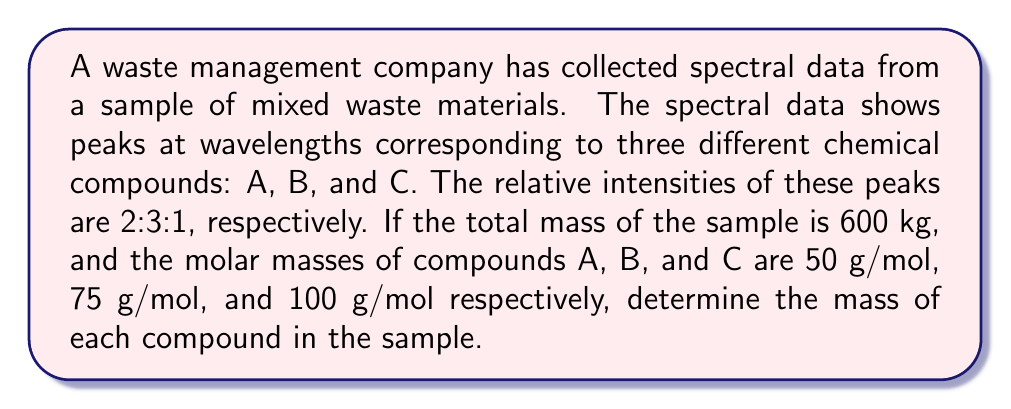Solve this math problem. Let's approach this step-by-step:

1) First, we need to understand that the relative intensities (2:3:1) correspond to the relative number of moles of each compound.

2) Let's define variables:
   $x$ = number of moles of compound A
   $y$ = number of moles of compound B
   $z$ = number of moles of compound C

3) We can set up the following equation based on the relative intensities:
   $$\frac{x}{2} = \frac{y}{3} = \frac{z}{1}$$

4) Let's express $y$ and $z$ in terms of $x$:
   $y = \frac{3x}{2}$ and $z = \frac{x}{2}$

5) Now, we can set up an equation for the total mass:
   $$50x + 75(\frac{3x}{2}) + 100(\frac{x}{2}) = 600,000$$

6) Simplify:
   $$50x + 112.5x + 50x = 600,000$$
   $$212.5x = 600,000$$

7) Solve for $x$:
   $$x = \frac{600,000}{212.5} = 2,823.53$$

8) Now we can calculate $y$ and $z$:
   $y = \frac{3x}{2} = \frac{3(2,823.53)}{2} = 4,235.29$
   $z = \frac{x}{2} = \frac{2,823.53}{2} = 1,411.76$

9) Finally, calculate the mass of each compound:
   A: $2,823.53 \times 50 = 141,176.5$ g = 141.18 kg
   B: $4,235.29 \times 75 = 317,646.75$ g = 317.65 kg
   C: $1,411.76 \times 100 = 141,176$ g = 141.18 kg
Answer: A: 141.18 kg, B: 317.65 kg, C: 141.18 kg 